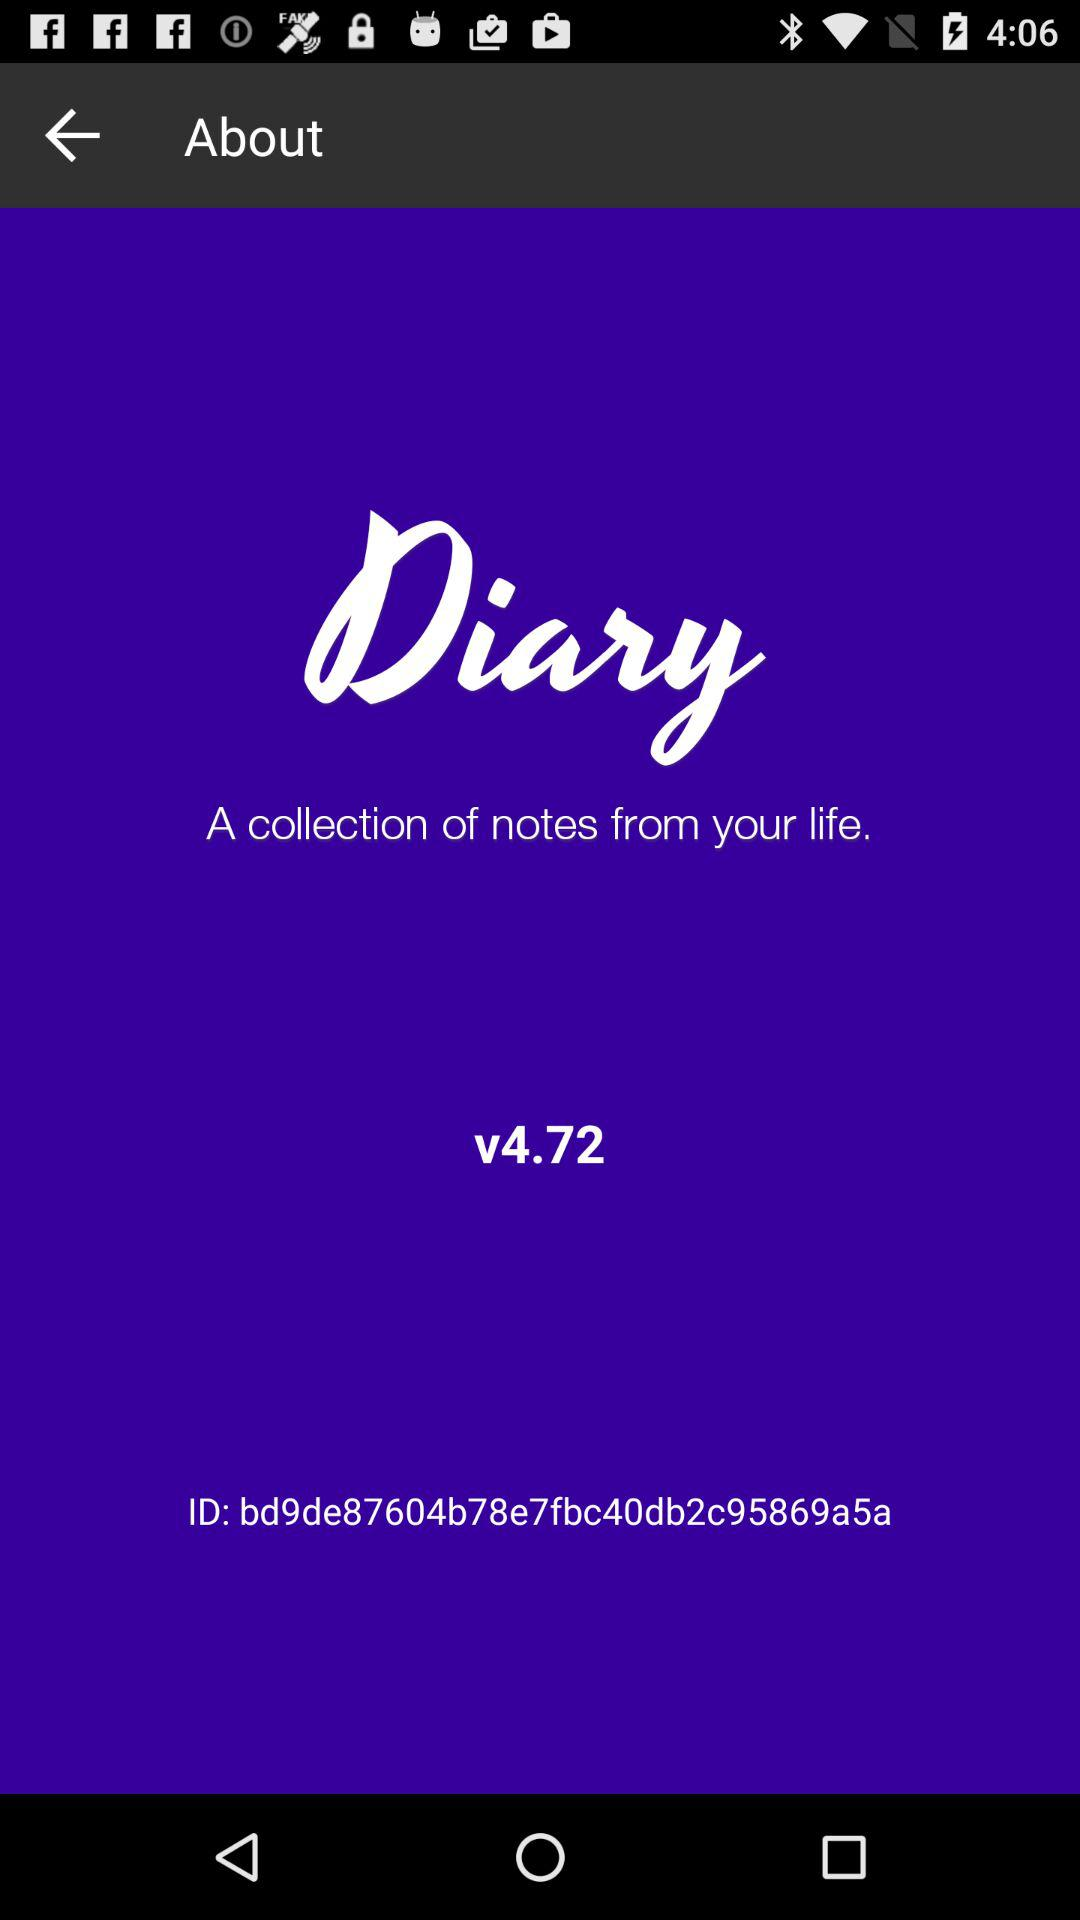What is the application name? The application name displayed in the image is 'Diary'. It's described as a platform for compiling personal notes, evident from its tagline 'A collection of notes from your life.' The app also shows its version as v4.72 at the bottom. 